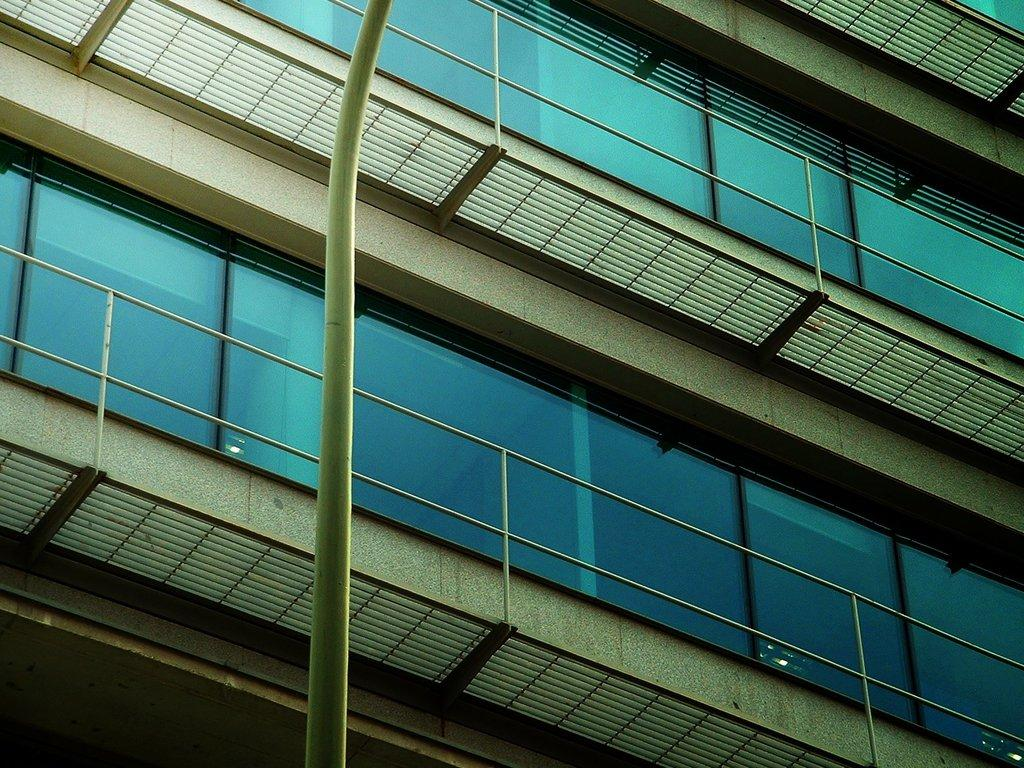What is the main object in the middle of the image? There is a pole in the middle of the image. What can be observed about the building in the image? The building in the image has many glass windows. How many hens are sitting on the pole in the image? There are no hens present in the image; it only features a pole and a building with glass windows. 